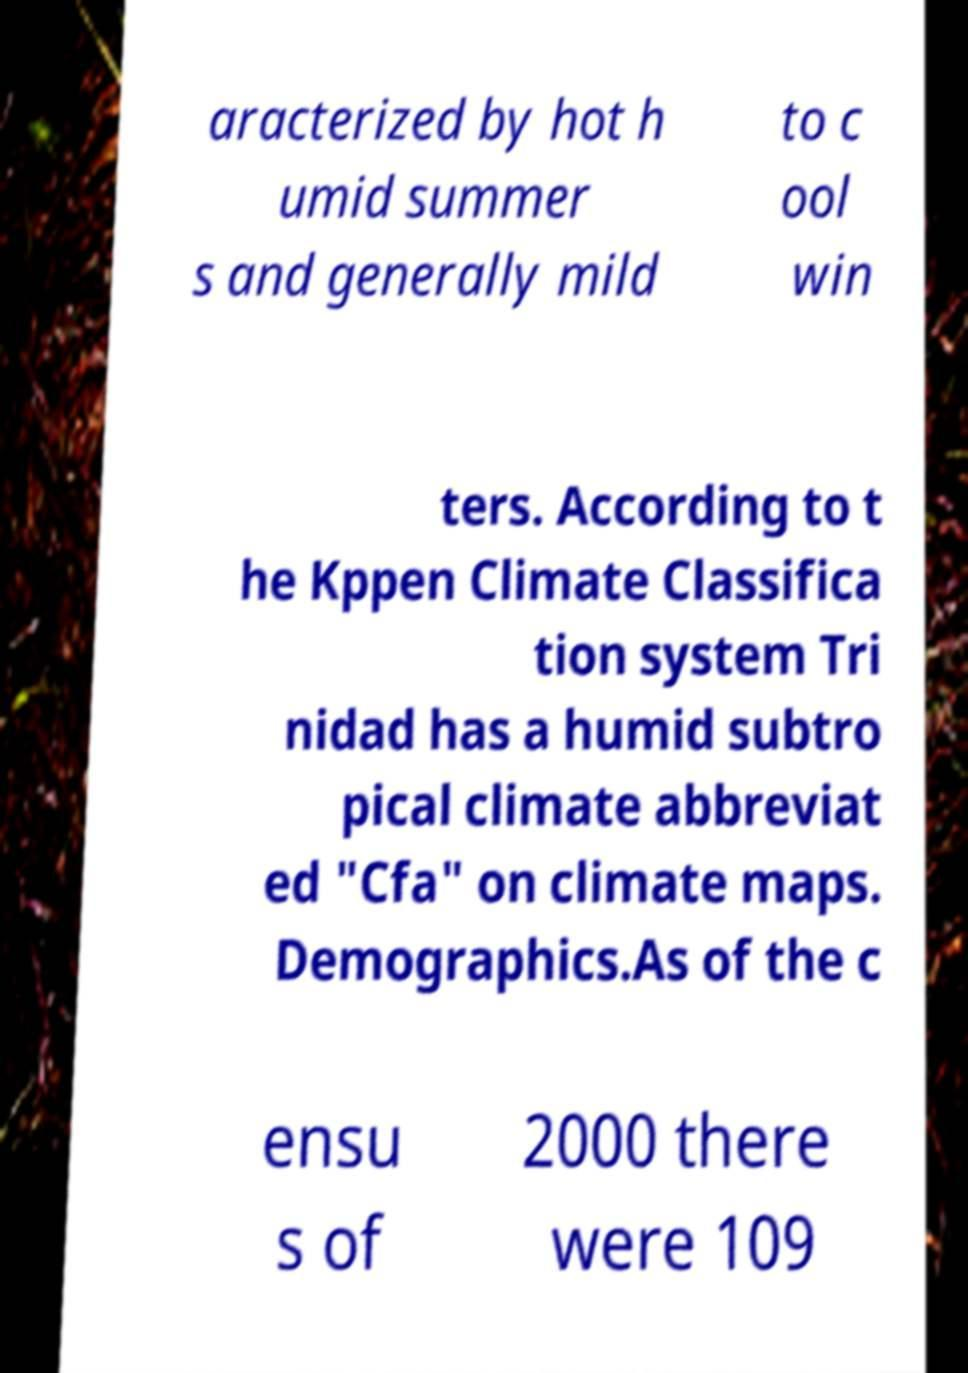Could you assist in decoding the text presented in this image and type it out clearly? aracterized by hot h umid summer s and generally mild to c ool win ters. According to t he Kppen Climate Classifica tion system Tri nidad has a humid subtro pical climate abbreviat ed "Cfa" on climate maps. Demographics.As of the c ensu s of 2000 there were 109 